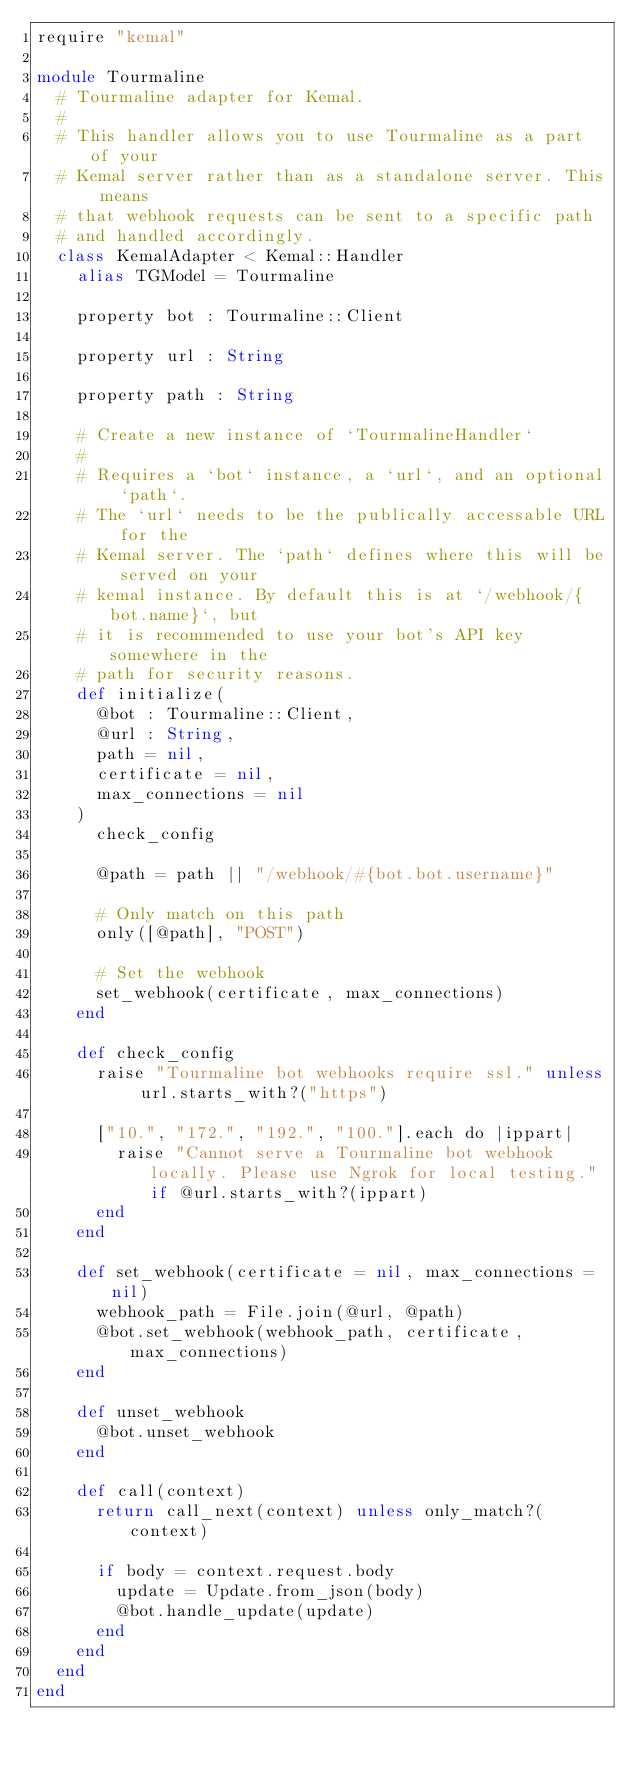<code> <loc_0><loc_0><loc_500><loc_500><_Crystal_>require "kemal"

module Tourmaline
  # Tourmaline adapter for Kemal.
  #
  # This handler allows you to use Tourmaline as a part of your
  # Kemal server rather than as a standalone server. This means
  # that webhook requests can be sent to a specific path
  # and handled accordingly.
  class KemalAdapter < Kemal::Handler
    alias TGModel = Tourmaline

    property bot : Tourmaline::Client

    property url : String

    property path : String

    # Create a new instance of `TourmalineHandler`
    #
    # Requires a `bot` instance, a `url`, and an optional `path`.
    # The `url` needs to be the publically accessable URL for the
    # Kemal server. The `path` defines where this will be served on your
    # kemal instance. By default this is at `/webhook/{bot.name}`, but
    # it is recommended to use your bot's API key somewhere in the
    # path for security reasons.
    def initialize(
      @bot : Tourmaline::Client,
      @url : String,
      path = nil,
      certificate = nil,
      max_connections = nil
    )
      check_config

      @path = path || "/webhook/#{bot.bot.username}"

      # Only match on this path
      only([@path], "POST")

      # Set the webhook
      set_webhook(certificate, max_connections)
    end

    def check_config
      raise "Tourmaline bot webhooks require ssl." unless url.starts_with?("https")

      ["10.", "172.", "192.", "100."].each do |ippart|
        raise "Cannot serve a Tourmaline bot webhook locally. Please use Ngrok for local testing." if @url.starts_with?(ippart)
      end
    end

    def set_webhook(certificate = nil, max_connections = nil)
      webhook_path = File.join(@url, @path)
      @bot.set_webhook(webhook_path, certificate, max_connections)
    end

    def unset_webhook
      @bot.unset_webhook
    end

    def call(context)
      return call_next(context) unless only_match?(context)

      if body = context.request.body
        update = Update.from_json(body)
        @bot.handle_update(update)
      end
    end
  end
end
</code> 